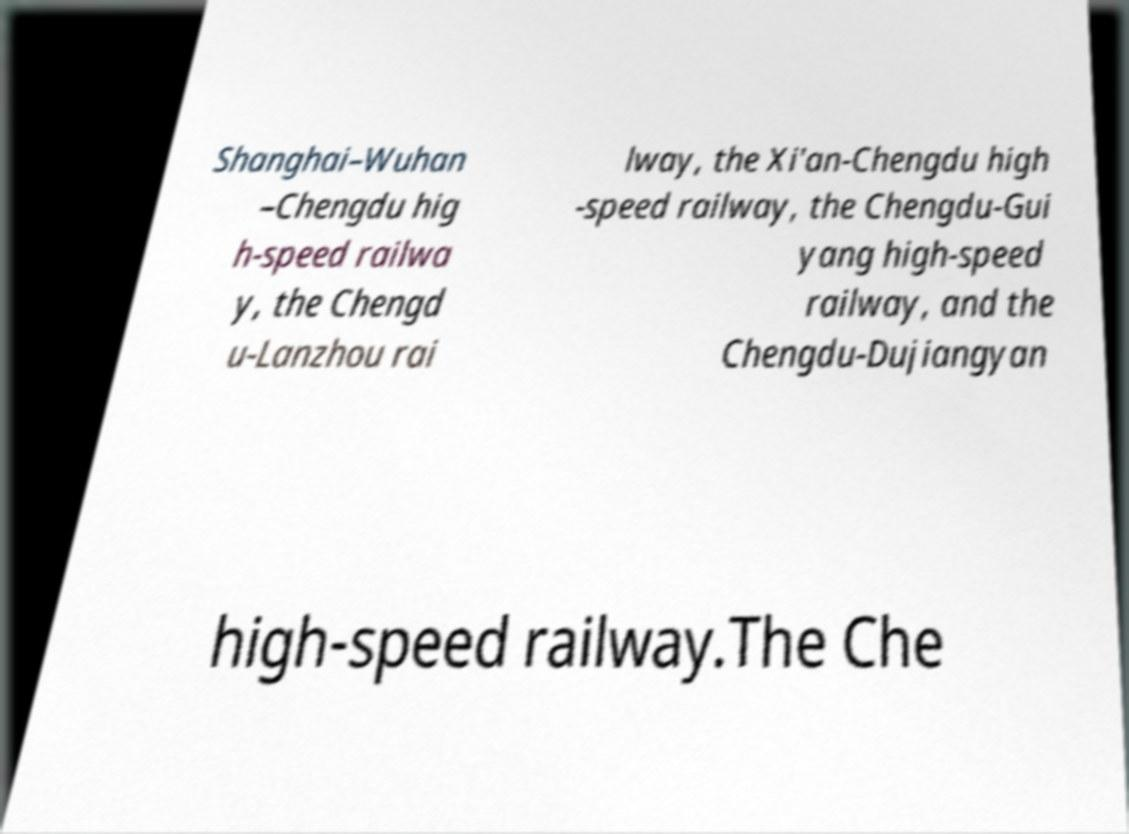What messages or text are displayed in this image? I need them in a readable, typed format. Shanghai–Wuhan –Chengdu hig h-speed railwa y, the Chengd u-Lanzhou rai lway, the Xi'an-Chengdu high -speed railway, the Chengdu-Gui yang high-speed railway, and the Chengdu-Dujiangyan high-speed railway.The Che 